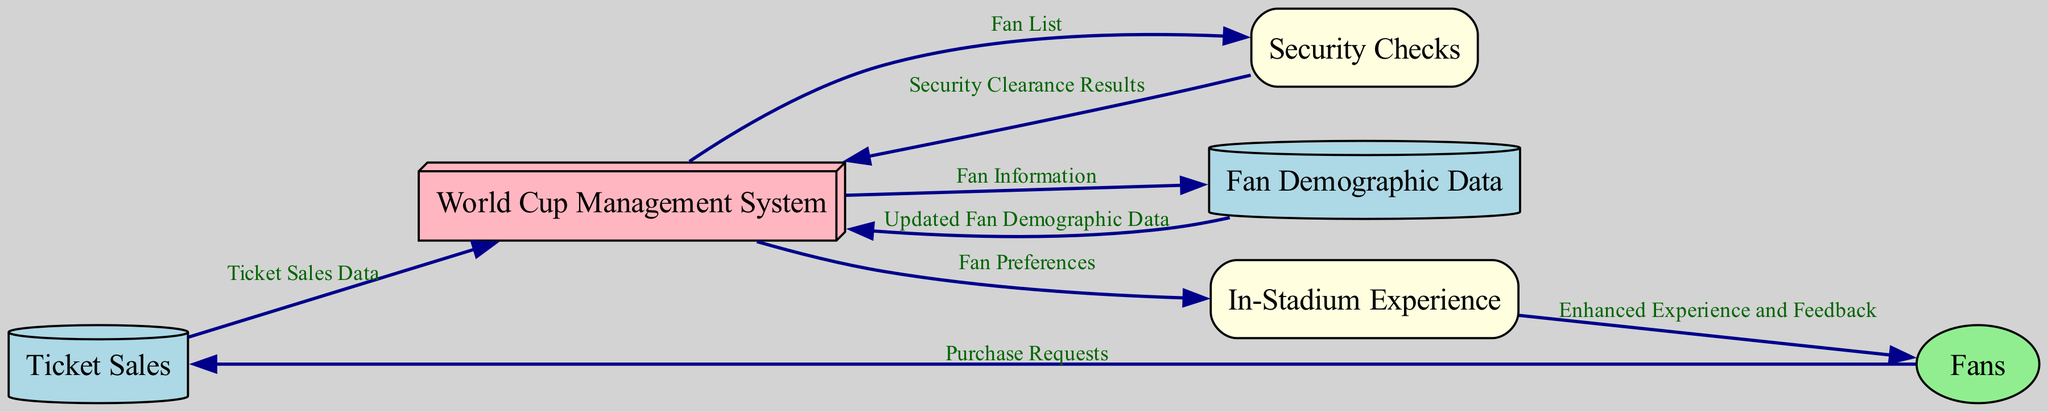What are the data sources in this diagram? The diagram identifies two data sources: "Ticket Sales" and "Fan Demographic Data." These sources are represented as distinct nodes in the diagram, allowing fans to interact with the ticketing and demographic systems.
Answer: Ticket Sales, Fan Demographic Data How many processes are shown in the diagram? There are two processes identified in the diagram: "Security Checks" and "In-Stadium Experience." These processes manage the flow of data between the different entities and data sources.
Answer: 2 What data flow originates from Fans? The data flow originating from "Fans" is labeled as "Purchase Requests" that lead to "Ticket Sales." This indicates that fans initiate the process by requesting tickets.
Answer: Purchase Requests What does the "World Cup Management System" send to "Security Checks"? The "World Cup Management System" sends a "Fan List" to the "Security Checks." This indicates the system's role in providing necessary information for security validations.
Answer: Fan List What type of data flow is indicated between "Security Checks" and "World Cup Management System"? The data flow between "Security Checks" and the "World Cup Management System" is labeled as "Security Clearance Results," highlighting the outcome of the security checks related to ticket holders.
Answer: Security Clearance Results How does "Fan Demographic Data" affect the "World Cup Management System"? The "Fan Demographic Data" provides "Updated Fan Demographic Data" back to the "World Cup Management System," which allows for refined insights into the fan base after the demographic information is analyzed.
Answer: Updated Fan Demographic Data What feedback do fans receive after the "In-Stadium Experience"? After the "In-Stadium Experience," fans receive "Enhanced Experience and Feedback," indicating the outcome of the processes aimed at ensuring an enjoyable event for attendees.
Answer: Enhanced Experience and Feedback Which process involves data about fan preferences? The process that involves data about fan preferences is "In-Stadium Experience," as it requires this information to tailor the experience provided to the fans.
Answer: In-Stadium Experience 